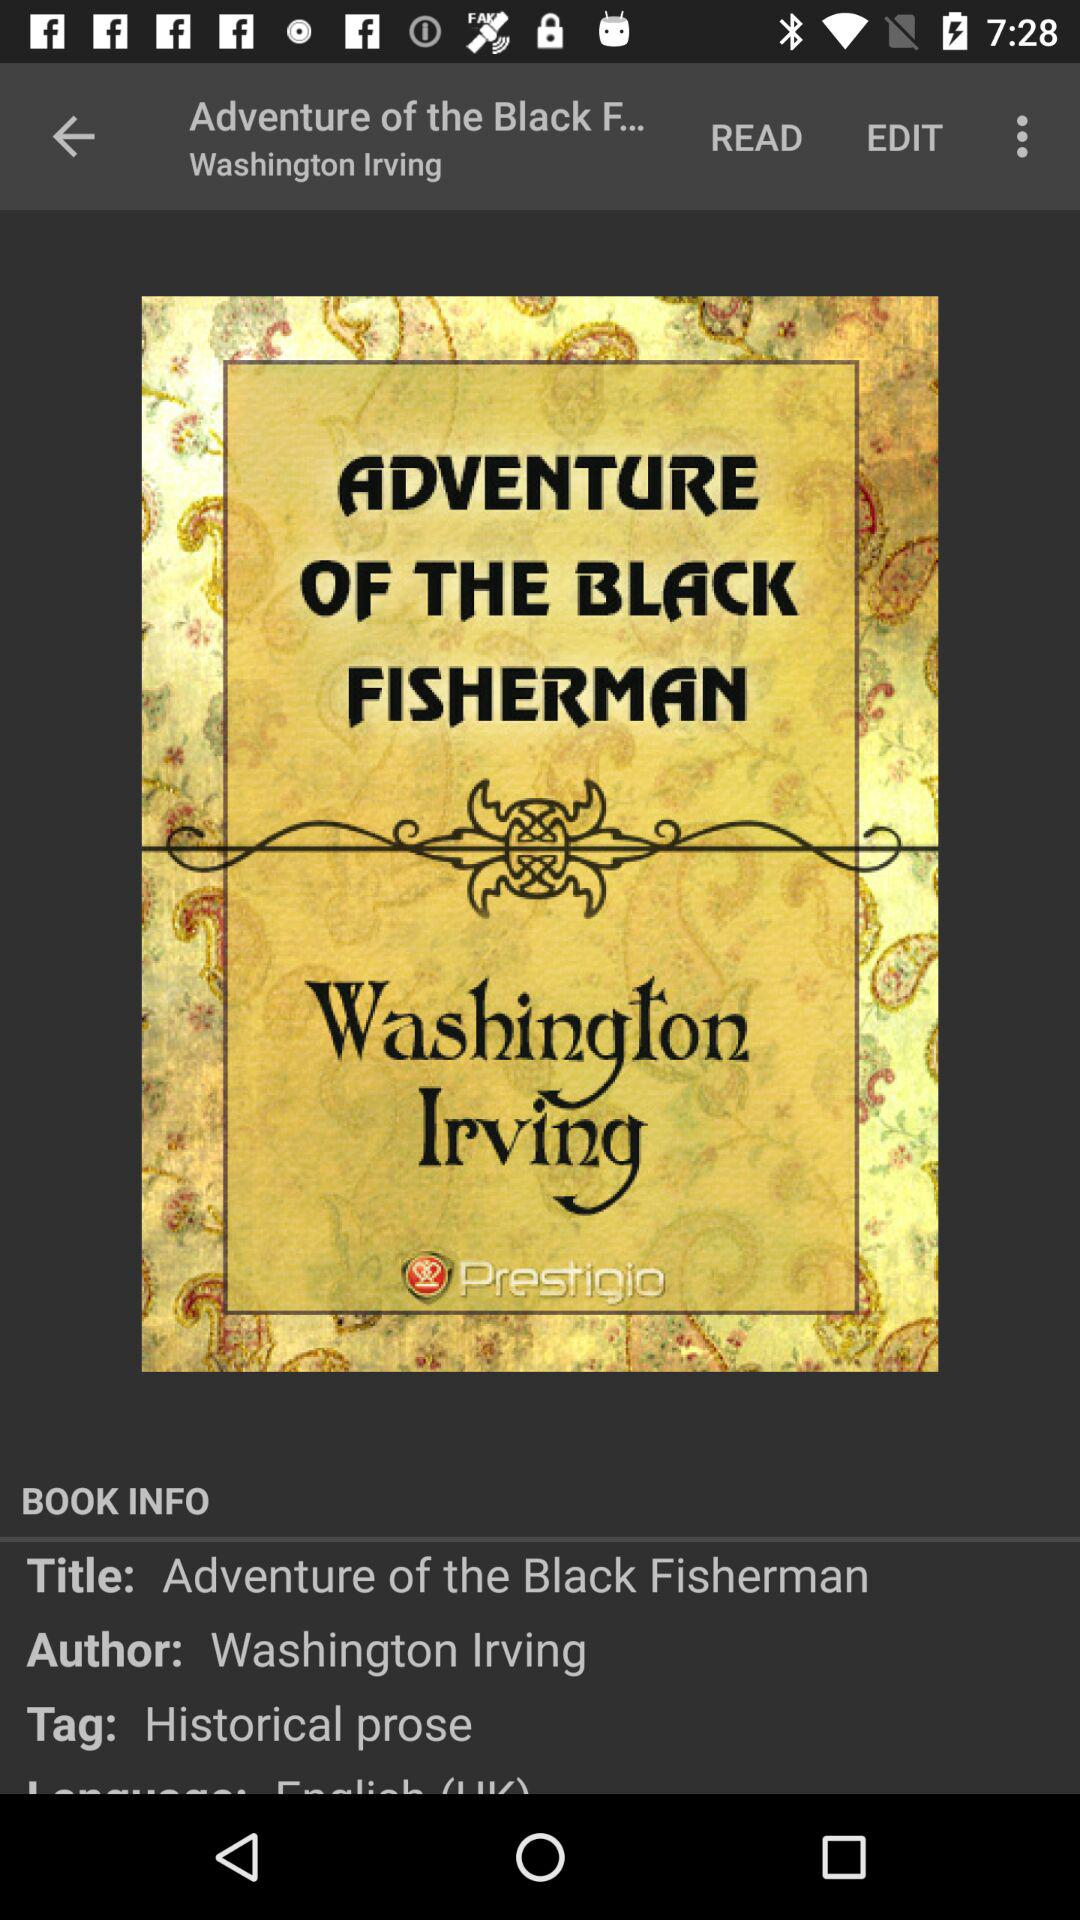Who's the author of the book? The author of the book is Washington Irving. 